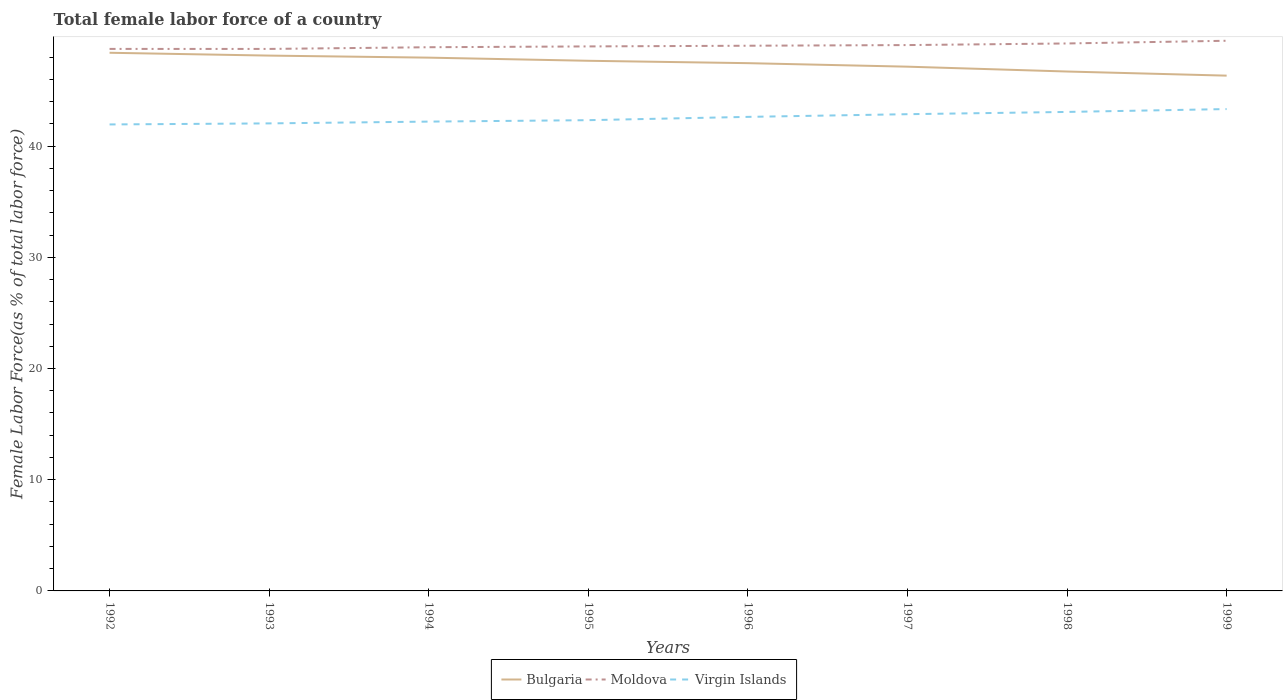Across all years, what is the maximum percentage of female labor force in Bulgaria?
Your answer should be compact. 46.34. What is the total percentage of female labor force in Virgin Islands in the graph?
Your answer should be very brief. -0.29. What is the difference between the highest and the second highest percentage of female labor force in Virgin Islands?
Give a very brief answer. 1.38. Is the percentage of female labor force in Moldova strictly greater than the percentage of female labor force in Virgin Islands over the years?
Give a very brief answer. No. How many lines are there?
Offer a very short reply. 3. Are the values on the major ticks of Y-axis written in scientific E-notation?
Your response must be concise. No. Where does the legend appear in the graph?
Ensure brevity in your answer.  Bottom center. What is the title of the graph?
Offer a very short reply. Total female labor force of a country. What is the label or title of the X-axis?
Make the answer very short. Years. What is the label or title of the Y-axis?
Your response must be concise. Female Labor Force(as % of total labor force). What is the Female Labor Force(as % of total labor force) of Bulgaria in 1992?
Make the answer very short. 48.39. What is the Female Labor Force(as % of total labor force) in Moldova in 1992?
Your response must be concise. 48.74. What is the Female Labor Force(as % of total labor force) in Virgin Islands in 1992?
Your response must be concise. 41.95. What is the Female Labor Force(as % of total labor force) in Bulgaria in 1993?
Your answer should be very brief. 48.14. What is the Female Labor Force(as % of total labor force) of Moldova in 1993?
Make the answer very short. 48.74. What is the Female Labor Force(as % of total labor force) of Virgin Islands in 1993?
Your answer should be very brief. 42.04. What is the Female Labor Force(as % of total labor force) of Bulgaria in 1994?
Give a very brief answer. 47.95. What is the Female Labor Force(as % of total labor force) in Moldova in 1994?
Give a very brief answer. 48.89. What is the Female Labor Force(as % of total labor force) in Virgin Islands in 1994?
Provide a succinct answer. 42.2. What is the Female Labor Force(as % of total labor force) of Bulgaria in 1995?
Make the answer very short. 47.67. What is the Female Labor Force(as % of total labor force) of Moldova in 1995?
Offer a very short reply. 48.96. What is the Female Labor Force(as % of total labor force) of Virgin Islands in 1995?
Provide a succinct answer. 42.33. What is the Female Labor Force(as % of total labor force) in Bulgaria in 1996?
Offer a terse response. 47.46. What is the Female Labor Force(as % of total labor force) of Moldova in 1996?
Make the answer very short. 49.03. What is the Female Labor Force(as % of total labor force) in Virgin Islands in 1996?
Offer a terse response. 42.63. What is the Female Labor Force(as % of total labor force) of Bulgaria in 1997?
Give a very brief answer. 47.14. What is the Female Labor Force(as % of total labor force) in Moldova in 1997?
Offer a very short reply. 49.08. What is the Female Labor Force(as % of total labor force) of Virgin Islands in 1997?
Your answer should be very brief. 42.87. What is the Female Labor Force(as % of total labor force) of Bulgaria in 1998?
Make the answer very short. 46.71. What is the Female Labor Force(as % of total labor force) of Moldova in 1998?
Offer a terse response. 49.23. What is the Female Labor Force(as % of total labor force) of Virgin Islands in 1998?
Give a very brief answer. 43.07. What is the Female Labor Force(as % of total labor force) of Bulgaria in 1999?
Offer a terse response. 46.34. What is the Female Labor Force(as % of total labor force) of Moldova in 1999?
Offer a very short reply. 49.47. What is the Female Labor Force(as % of total labor force) in Virgin Islands in 1999?
Keep it short and to the point. 43.33. Across all years, what is the maximum Female Labor Force(as % of total labor force) of Bulgaria?
Keep it short and to the point. 48.39. Across all years, what is the maximum Female Labor Force(as % of total labor force) of Moldova?
Ensure brevity in your answer.  49.47. Across all years, what is the maximum Female Labor Force(as % of total labor force) of Virgin Islands?
Provide a succinct answer. 43.33. Across all years, what is the minimum Female Labor Force(as % of total labor force) in Bulgaria?
Provide a short and direct response. 46.34. Across all years, what is the minimum Female Labor Force(as % of total labor force) of Moldova?
Your answer should be very brief. 48.74. Across all years, what is the minimum Female Labor Force(as % of total labor force) of Virgin Islands?
Provide a short and direct response. 41.95. What is the total Female Labor Force(as % of total labor force) in Bulgaria in the graph?
Your answer should be very brief. 379.8. What is the total Female Labor Force(as % of total labor force) in Moldova in the graph?
Keep it short and to the point. 392.14. What is the total Female Labor Force(as % of total labor force) in Virgin Islands in the graph?
Provide a succinct answer. 340.42. What is the difference between the Female Labor Force(as % of total labor force) in Bulgaria in 1992 and that in 1993?
Ensure brevity in your answer.  0.26. What is the difference between the Female Labor Force(as % of total labor force) of Moldova in 1992 and that in 1993?
Provide a short and direct response. 0. What is the difference between the Female Labor Force(as % of total labor force) in Virgin Islands in 1992 and that in 1993?
Provide a succinct answer. -0.1. What is the difference between the Female Labor Force(as % of total labor force) of Bulgaria in 1992 and that in 1994?
Keep it short and to the point. 0.44. What is the difference between the Female Labor Force(as % of total labor force) of Moldova in 1992 and that in 1994?
Ensure brevity in your answer.  -0.15. What is the difference between the Female Labor Force(as % of total labor force) of Virgin Islands in 1992 and that in 1994?
Your response must be concise. -0.26. What is the difference between the Female Labor Force(as % of total labor force) in Bulgaria in 1992 and that in 1995?
Provide a succinct answer. 0.72. What is the difference between the Female Labor Force(as % of total labor force) of Moldova in 1992 and that in 1995?
Give a very brief answer. -0.22. What is the difference between the Female Labor Force(as % of total labor force) of Virgin Islands in 1992 and that in 1995?
Offer a very short reply. -0.38. What is the difference between the Female Labor Force(as % of total labor force) in Bulgaria in 1992 and that in 1996?
Your response must be concise. 0.93. What is the difference between the Female Labor Force(as % of total labor force) of Moldova in 1992 and that in 1996?
Offer a terse response. -0.29. What is the difference between the Female Labor Force(as % of total labor force) in Virgin Islands in 1992 and that in 1996?
Keep it short and to the point. -0.68. What is the difference between the Female Labor Force(as % of total labor force) of Bulgaria in 1992 and that in 1997?
Keep it short and to the point. 1.25. What is the difference between the Female Labor Force(as % of total labor force) of Moldova in 1992 and that in 1997?
Provide a succinct answer. -0.34. What is the difference between the Female Labor Force(as % of total labor force) in Virgin Islands in 1992 and that in 1997?
Keep it short and to the point. -0.92. What is the difference between the Female Labor Force(as % of total labor force) in Bulgaria in 1992 and that in 1998?
Give a very brief answer. 1.69. What is the difference between the Female Labor Force(as % of total labor force) of Moldova in 1992 and that in 1998?
Offer a terse response. -0.49. What is the difference between the Female Labor Force(as % of total labor force) in Virgin Islands in 1992 and that in 1998?
Give a very brief answer. -1.13. What is the difference between the Female Labor Force(as % of total labor force) in Bulgaria in 1992 and that in 1999?
Offer a terse response. 2.06. What is the difference between the Female Labor Force(as % of total labor force) of Moldova in 1992 and that in 1999?
Offer a terse response. -0.73. What is the difference between the Female Labor Force(as % of total labor force) of Virgin Islands in 1992 and that in 1999?
Your answer should be very brief. -1.38. What is the difference between the Female Labor Force(as % of total labor force) in Bulgaria in 1993 and that in 1994?
Offer a terse response. 0.18. What is the difference between the Female Labor Force(as % of total labor force) in Moldova in 1993 and that in 1994?
Make the answer very short. -0.15. What is the difference between the Female Labor Force(as % of total labor force) of Virgin Islands in 1993 and that in 1994?
Your answer should be compact. -0.16. What is the difference between the Female Labor Force(as % of total labor force) of Bulgaria in 1993 and that in 1995?
Make the answer very short. 0.47. What is the difference between the Female Labor Force(as % of total labor force) of Moldova in 1993 and that in 1995?
Offer a very short reply. -0.23. What is the difference between the Female Labor Force(as % of total labor force) in Virgin Islands in 1993 and that in 1995?
Give a very brief answer. -0.29. What is the difference between the Female Labor Force(as % of total labor force) in Bulgaria in 1993 and that in 1996?
Give a very brief answer. 0.68. What is the difference between the Female Labor Force(as % of total labor force) in Moldova in 1993 and that in 1996?
Your response must be concise. -0.29. What is the difference between the Female Labor Force(as % of total labor force) of Virgin Islands in 1993 and that in 1996?
Keep it short and to the point. -0.59. What is the difference between the Female Labor Force(as % of total labor force) of Moldova in 1993 and that in 1997?
Offer a very short reply. -0.35. What is the difference between the Female Labor Force(as % of total labor force) in Virgin Islands in 1993 and that in 1997?
Provide a succinct answer. -0.83. What is the difference between the Female Labor Force(as % of total labor force) of Bulgaria in 1993 and that in 1998?
Make the answer very short. 1.43. What is the difference between the Female Labor Force(as % of total labor force) in Moldova in 1993 and that in 1998?
Offer a very short reply. -0.49. What is the difference between the Female Labor Force(as % of total labor force) in Virgin Islands in 1993 and that in 1998?
Give a very brief answer. -1.03. What is the difference between the Female Labor Force(as % of total labor force) in Bulgaria in 1993 and that in 1999?
Offer a terse response. 1.8. What is the difference between the Female Labor Force(as % of total labor force) of Moldova in 1993 and that in 1999?
Your answer should be very brief. -0.73. What is the difference between the Female Labor Force(as % of total labor force) of Virgin Islands in 1993 and that in 1999?
Give a very brief answer. -1.29. What is the difference between the Female Labor Force(as % of total labor force) of Bulgaria in 1994 and that in 1995?
Provide a short and direct response. 0.28. What is the difference between the Female Labor Force(as % of total labor force) in Moldova in 1994 and that in 1995?
Keep it short and to the point. -0.07. What is the difference between the Female Labor Force(as % of total labor force) in Virgin Islands in 1994 and that in 1995?
Keep it short and to the point. -0.13. What is the difference between the Female Labor Force(as % of total labor force) of Bulgaria in 1994 and that in 1996?
Provide a succinct answer. 0.5. What is the difference between the Female Labor Force(as % of total labor force) of Moldova in 1994 and that in 1996?
Make the answer very short. -0.13. What is the difference between the Female Labor Force(as % of total labor force) of Virgin Islands in 1994 and that in 1996?
Provide a short and direct response. -0.42. What is the difference between the Female Labor Force(as % of total labor force) of Bulgaria in 1994 and that in 1997?
Provide a short and direct response. 0.81. What is the difference between the Female Labor Force(as % of total labor force) of Moldova in 1994 and that in 1997?
Your answer should be very brief. -0.19. What is the difference between the Female Labor Force(as % of total labor force) of Virgin Islands in 1994 and that in 1997?
Offer a terse response. -0.67. What is the difference between the Female Labor Force(as % of total labor force) of Bulgaria in 1994 and that in 1998?
Your answer should be compact. 1.25. What is the difference between the Female Labor Force(as % of total labor force) in Moldova in 1994 and that in 1998?
Your response must be concise. -0.34. What is the difference between the Female Labor Force(as % of total labor force) of Virgin Islands in 1994 and that in 1998?
Your response must be concise. -0.87. What is the difference between the Female Labor Force(as % of total labor force) in Bulgaria in 1994 and that in 1999?
Provide a succinct answer. 1.62. What is the difference between the Female Labor Force(as % of total labor force) of Moldova in 1994 and that in 1999?
Provide a succinct answer. -0.58. What is the difference between the Female Labor Force(as % of total labor force) of Virgin Islands in 1994 and that in 1999?
Your response must be concise. -1.13. What is the difference between the Female Labor Force(as % of total labor force) in Bulgaria in 1995 and that in 1996?
Make the answer very short. 0.21. What is the difference between the Female Labor Force(as % of total labor force) of Moldova in 1995 and that in 1996?
Your response must be concise. -0.06. What is the difference between the Female Labor Force(as % of total labor force) of Virgin Islands in 1995 and that in 1996?
Offer a terse response. -0.3. What is the difference between the Female Labor Force(as % of total labor force) of Bulgaria in 1995 and that in 1997?
Provide a succinct answer. 0.53. What is the difference between the Female Labor Force(as % of total labor force) in Moldova in 1995 and that in 1997?
Offer a terse response. -0.12. What is the difference between the Female Labor Force(as % of total labor force) in Virgin Islands in 1995 and that in 1997?
Your answer should be compact. -0.54. What is the difference between the Female Labor Force(as % of total labor force) of Bulgaria in 1995 and that in 1998?
Your answer should be compact. 0.97. What is the difference between the Female Labor Force(as % of total labor force) in Moldova in 1995 and that in 1998?
Offer a very short reply. -0.27. What is the difference between the Female Labor Force(as % of total labor force) of Virgin Islands in 1995 and that in 1998?
Ensure brevity in your answer.  -0.74. What is the difference between the Female Labor Force(as % of total labor force) of Bulgaria in 1995 and that in 1999?
Provide a short and direct response. 1.34. What is the difference between the Female Labor Force(as % of total labor force) of Moldova in 1995 and that in 1999?
Offer a terse response. -0.51. What is the difference between the Female Labor Force(as % of total labor force) of Virgin Islands in 1995 and that in 1999?
Keep it short and to the point. -1. What is the difference between the Female Labor Force(as % of total labor force) of Bulgaria in 1996 and that in 1997?
Offer a terse response. 0.32. What is the difference between the Female Labor Force(as % of total labor force) of Moldova in 1996 and that in 1997?
Your response must be concise. -0.06. What is the difference between the Female Labor Force(as % of total labor force) in Virgin Islands in 1996 and that in 1997?
Keep it short and to the point. -0.24. What is the difference between the Female Labor Force(as % of total labor force) of Bulgaria in 1996 and that in 1998?
Ensure brevity in your answer.  0.75. What is the difference between the Female Labor Force(as % of total labor force) of Moldova in 1996 and that in 1998?
Ensure brevity in your answer.  -0.2. What is the difference between the Female Labor Force(as % of total labor force) of Virgin Islands in 1996 and that in 1998?
Offer a very short reply. -0.44. What is the difference between the Female Labor Force(as % of total labor force) of Bulgaria in 1996 and that in 1999?
Offer a terse response. 1.12. What is the difference between the Female Labor Force(as % of total labor force) of Moldova in 1996 and that in 1999?
Make the answer very short. -0.45. What is the difference between the Female Labor Force(as % of total labor force) in Virgin Islands in 1996 and that in 1999?
Your answer should be very brief. -0.7. What is the difference between the Female Labor Force(as % of total labor force) in Bulgaria in 1997 and that in 1998?
Provide a short and direct response. 0.44. What is the difference between the Female Labor Force(as % of total labor force) of Moldova in 1997 and that in 1998?
Keep it short and to the point. -0.15. What is the difference between the Female Labor Force(as % of total labor force) in Virgin Islands in 1997 and that in 1998?
Offer a terse response. -0.2. What is the difference between the Female Labor Force(as % of total labor force) in Bulgaria in 1997 and that in 1999?
Keep it short and to the point. 0.81. What is the difference between the Female Labor Force(as % of total labor force) in Moldova in 1997 and that in 1999?
Offer a very short reply. -0.39. What is the difference between the Female Labor Force(as % of total labor force) of Virgin Islands in 1997 and that in 1999?
Your answer should be compact. -0.46. What is the difference between the Female Labor Force(as % of total labor force) of Bulgaria in 1998 and that in 1999?
Keep it short and to the point. 0.37. What is the difference between the Female Labor Force(as % of total labor force) of Moldova in 1998 and that in 1999?
Keep it short and to the point. -0.24. What is the difference between the Female Labor Force(as % of total labor force) of Virgin Islands in 1998 and that in 1999?
Provide a short and direct response. -0.26. What is the difference between the Female Labor Force(as % of total labor force) of Bulgaria in 1992 and the Female Labor Force(as % of total labor force) of Moldova in 1993?
Give a very brief answer. -0.34. What is the difference between the Female Labor Force(as % of total labor force) in Bulgaria in 1992 and the Female Labor Force(as % of total labor force) in Virgin Islands in 1993?
Make the answer very short. 6.35. What is the difference between the Female Labor Force(as % of total labor force) of Moldova in 1992 and the Female Labor Force(as % of total labor force) of Virgin Islands in 1993?
Ensure brevity in your answer.  6.7. What is the difference between the Female Labor Force(as % of total labor force) in Bulgaria in 1992 and the Female Labor Force(as % of total labor force) in Moldova in 1994?
Make the answer very short. -0.5. What is the difference between the Female Labor Force(as % of total labor force) of Bulgaria in 1992 and the Female Labor Force(as % of total labor force) of Virgin Islands in 1994?
Make the answer very short. 6.19. What is the difference between the Female Labor Force(as % of total labor force) in Moldova in 1992 and the Female Labor Force(as % of total labor force) in Virgin Islands in 1994?
Keep it short and to the point. 6.54. What is the difference between the Female Labor Force(as % of total labor force) in Bulgaria in 1992 and the Female Labor Force(as % of total labor force) in Moldova in 1995?
Ensure brevity in your answer.  -0.57. What is the difference between the Female Labor Force(as % of total labor force) in Bulgaria in 1992 and the Female Labor Force(as % of total labor force) in Virgin Islands in 1995?
Make the answer very short. 6.06. What is the difference between the Female Labor Force(as % of total labor force) of Moldova in 1992 and the Female Labor Force(as % of total labor force) of Virgin Islands in 1995?
Give a very brief answer. 6.41. What is the difference between the Female Labor Force(as % of total labor force) of Bulgaria in 1992 and the Female Labor Force(as % of total labor force) of Moldova in 1996?
Your answer should be very brief. -0.63. What is the difference between the Female Labor Force(as % of total labor force) of Bulgaria in 1992 and the Female Labor Force(as % of total labor force) of Virgin Islands in 1996?
Your answer should be compact. 5.76. What is the difference between the Female Labor Force(as % of total labor force) of Moldova in 1992 and the Female Labor Force(as % of total labor force) of Virgin Islands in 1996?
Offer a terse response. 6.11. What is the difference between the Female Labor Force(as % of total labor force) of Bulgaria in 1992 and the Female Labor Force(as % of total labor force) of Moldova in 1997?
Your answer should be compact. -0.69. What is the difference between the Female Labor Force(as % of total labor force) of Bulgaria in 1992 and the Female Labor Force(as % of total labor force) of Virgin Islands in 1997?
Make the answer very short. 5.52. What is the difference between the Female Labor Force(as % of total labor force) of Moldova in 1992 and the Female Labor Force(as % of total labor force) of Virgin Islands in 1997?
Your answer should be compact. 5.87. What is the difference between the Female Labor Force(as % of total labor force) of Bulgaria in 1992 and the Female Labor Force(as % of total labor force) of Moldova in 1998?
Offer a terse response. -0.84. What is the difference between the Female Labor Force(as % of total labor force) of Bulgaria in 1992 and the Female Labor Force(as % of total labor force) of Virgin Islands in 1998?
Offer a terse response. 5.32. What is the difference between the Female Labor Force(as % of total labor force) of Moldova in 1992 and the Female Labor Force(as % of total labor force) of Virgin Islands in 1998?
Ensure brevity in your answer.  5.67. What is the difference between the Female Labor Force(as % of total labor force) in Bulgaria in 1992 and the Female Labor Force(as % of total labor force) in Moldova in 1999?
Ensure brevity in your answer.  -1.08. What is the difference between the Female Labor Force(as % of total labor force) of Bulgaria in 1992 and the Female Labor Force(as % of total labor force) of Virgin Islands in 1999?
Offer a terse response. 5.06. What is the difference between the Female Labor Force(as % of total labor force) of Moldova in 1992 and the Female Labor Force(as % of total labor force) of Virgin Islands in 1999?
Keep it short and to the point. 5.41. What is the difference between the Female Labor Force(as % of total labor force) of Bulgaria in 1993 and the Female Labor Force(as % of total labor force) of Moldova in 1994?
Your answer should be very brief. -0.75. What is the difference between the Female Labor Force(as % of total labor force) in Bulgaria in 1993 and the Female Labor Force(as % of total labor force) in Virgin Islands in 1994?
Keep it short and to the point. 5.93. What is the difference between the Female Labor Force(as % of total labor force) in Moldova in 1993 and the Female Labor Force(as % of total labor force) in Virgin Islands in 1994?
Offer a terse response. 6.53. What is the difference between the Female Labor Force(as % of total labor force) of Bulgaria in 1993 and the Female Labor Force(as % of total labor force) of Moldova in 1995?
Provide a succinct answer. -0.83. What is the difference between the Female Labor Force(as % of total labor force) of Bulgaria in 1993 and the Female Labor Force(as % of total labor force) of Virgin Islands in 1995?
Your response must be concise. 5.81. What is the difference between the Female Labor Force(as % of total labor force) in Moldova in 1993 and the Female Labor Force(as % of total labor force) in Virgin Islands in 1995?
Your answer should be compact. 6.41. What is the difference between the Female Labor Force(as % of total labor force) in Bulgaria in 1993 and the Female Labor Force(as % of total labor force) in Moldova in 1996?
Provide a succinct answer. -0.89. What is the difference between the Female Labor Force(as % of total labor force) in Bulgaria in 1993 and the Female Labor Force(as % of total labor force) in Virgin Islands in 1996?
Make the answer very short. 5.51. What is the difference between the Female Labor Force(as % of total labor force) in Moldova in 1993 and the Female Labor Force(as % of total labor force) in Virgin Islands in 1996?
Your answer should be compact. 6.11. What is the difference between the Female Labor Force(as % of total labor force) of Bulgaria in 1993 and the Female Labor Force(as % of total labor force) of Moldova in 1997?
Your response must be concise. -0.95. What is the difference between the Female Labor Force(as % of total labor force) in Bulgaria in 1993 and the Female Labor Force(as % of total labor force) in Virgin Islands in 1997?
Ensure brevity in your answer.  5.27. What is the difference between the Female Labor Force(as % of total labor force) of Moldova in 1993 and the Female Labor Force(as % of total labor force) of Virgin Islands in 1997?
Make the answer very short. 5.87. What is the difference between the Female Labor Force(as % of total labor force) in Bulgaria in 1993 and the Female Labor Force(as % of total labor force) in Moldova in 1998?
Provide a succinct answer. -1.09. What is the difference between the Female Labor Force(as % of total labor force) of Bulgaria in 1993 and the Female Labor Force(as % of total labor force) of Virgin Islands in 1998?
Provide a succinct answer. 5.07. What is the difference between the Female Labor Force(as % of total labor force) of Moldova in 1993 and the Female Labor Force(as % of total labor force) of Virgin Islands in 1998?
Give a very brief answer. 5.67. What is the difference between the Female Labor Force(as % of total labor force) of Bulgaria in 1993 and the Female Labor Force(as % of total labor force) of Moldova in 1999?
Provide a short and direct response. -1.33. What is the difference between the Female Labor Force(as % of total labor force) of Bulgaria in 1993 and the Female Labor Force(as % of total labor force) of Virgin Islands in 1999?
Provide a short and direct response. 4.81. What is the difference between the Female Labor Force(as % of total labor force) of Moldova in 1993 and the Female Labor Force(as % of total labor force) of Virgin Islands in 1999?
Your answer should be very brief. 5.41. What is the difference between the Female Labor Force(as % of total labor force) in Bulgaria in 1994 and the Female Labor Force(as % of total labor force) in Moldova in 1995?
Ensure brevity in your answer.  -1.01. What is the difference between the Female Labor Force(as % of total labor force) of Bulgaria in 1994 and the Female Labor Force(as % of total labor force) of Virgin Islands in 1995?
Offer a terse response. 5.62. What is the difference between the Female Labor Force(as % of total labor force) of Moldova in 1994 and the Female Labor Force(as % of total labor force) of Virgin Islands in 1995?
Keep it short and to the point. 6.56. What is the difference between the Female Labor Force(as % of total labor force) of Bulgaria in 1994 and the Female Labor Force(as % of total labor force) of Moldova in 1996?
Provide a succinct answer. -1.07. What is the difference between the Female Labor Force(as % of total labor force) in Bulgaria in 1994 and the Female Labor Force(as % of total labor force) in Virgin Islands in 1996?
Offer a terse response. 5.33. What is the difference between the Female Labor Force(as % of total labor force) in Moldova in 1994 and the Female Labor Force(as % of total labor force) in Virgin Islands in 1996?
Your answer should be compact. 6.26. What is the difference between the Female Labor Force(as % of total labor force) of Bulgaria in 1994 and the Female Labor Force(as % of total labor force) of Moldova in 1997?
Your answer should be very brief. -1.13. What is the difference between the Female Labor Force(as % of total labor force) of Bulgaria in 1994 and the Female Labor Force(as % of total labor force) of Virgin Islands in 1997?
Offer a very short reply. 5.09. What is the difference between the Female Labor Force(as % of total labor force) in Moldova in 1994 and the Female Labor Force(as % of total labor force) in Virgin Islands in 1997?
Your answer should be compact. 6.02. What is the difference between the Female Labor Force(as % of total labor force) in Bulgaria in 1994 and the Female Labor Force(as % of total labor force) in Moldova in 1998?
Provide a short and direct response. -1.27. What is the difference between the Female Labor Force(as % of total labor force) of Bulgaria in 1994 and the Female Labor Force(as % of total labor force) of Virgin Islands in 1998?
Offer a very short reply. 4.88. What is the difference between the Female Labor Force(as % of total labor force) in Moldova in 1994 and the Female Labor Force(as % of total labor force) in Virgin Islands in 1998?
Give a very brief answer. 5.82. What is the difference between the Female Labor Force(as % of total labor force) of Bulgaria in 1994 and the Female Labor Force(as % of total labor force) of Moldova in 1999?
Your answer should be compact. -1.52. What is the difference between the Female Labor Force(as % of total labor force) in Bulgaria in 1994 and the Female Labor Force(as % of total labor force) in Virgin Islands in 1999?
Make the answer very short. 4.62. What is the difference between the Female Labor Force(as % of total labor force) in Moldova in 1994 and the Female Labor Force(as % of total labor force) in Virgin Islands in 1999?
Your response must be concise. 5.56. What is the difference between the Female Labor Force(as % of total labor force) of Bulgaria in 1995 and the Female Labor Force(as % of total labor force) of Moldova in 1996?
Offer a terse response. -1.35. What is the difference between the Female Labor Force(as % of total labor force) in Bulgaria in 1995 and the Female Labor Force(as % of total labor force) in Virgin Islands in 1996?
Your answer should be very brief. 5.04. What is the difference between the Female Labor Force(as % of total labor force) in Moldova in 1995 and the Female Labor Force(as % of total labor force) in Virgin Islands in 1996?
Make the answer very short. 6.34. What is the difference between the Female Labor Force(as % of total labor force) of Bulgaria in 1995 and the Female Labor Force(as % of total labor force) of Moldova in 1997?
Your response must be concise. -1.41. What is the difference between the Female Labor Force(as % of total labor force) in Bulgaria in 1995 and the Female Labor Force(as % of total labor force) in Virgin Islands in 1997?
Ensure brevity in your answer.  4.8. What is the difference between the Female Labor Force(as % of total labor force) in Moldova in 1995 and the Female Labor Force(as % of total labor force) in Virgin Islands in 1997?
Keep it short and to the point. 6.09. What is the difference between the Female Labor Force(as % of total labor force) in Bulgaria in 1995 and the Female Labor Force(as % of total labor force) in Moldova in 1998?
Give a very brief answer. -1.56. What is the difference between the Female Labor Force(as % of total labor force) of Bulgaria in 1995 and the Female Labor Force(as % of total labor force) of Virgin Islands in 1998?
Provide a succinct answer. 4.6. What is the difference between the Female Labor Force(as % of total labor force) of Moldova in 1995 and the Female Labor Force(as % of total labor force) of Virgin Islands in 1998?
Ensure brevity in your answer.  5.89. What is the difference between the Female Labor Force(as % of total labor force) in Bulgaria in 1995 and the Female Labor Force(as % of total labor force) in Moldova in 1999?
Ensure brevity in your answer.  -1.8. What is the difference between the Female Labor Force(as % of total labor force) in Bulgaria in 1995 and the Female Labor Force(as % of total labor force) in Virgin Islands in 1999?
Give a very brief answer. 4.34. What is the difference between the Female Labor Force(as % of total labor force) in Moldova in 1995 and the Female Labor Force(as % of total labor force) in Virgin Islands in 1999?
Give a very brief answer. 5.63. What is the difference between the Female Labor Force(as % of total labor force) of Bulgaria in 1996 and the Female Labor Force(as % of total labor force) of Moldova in 1997?
Ensure brevity in your answer.  -1.63. What is the difference between the Female Labor Force(as % of total labor force) in Bulgaria in 1996 and the Female Labor Force(as % of total labor force) in Virgin Islands in 1997?
Your answer should be compact. 4.59. What is the difference between the Female Labor Force(as % of total labor force) of Moldova in 1996 and the Female Labor Force(as % of total labor force) of Virgin Islands in 1997?
Offer a terse response. 6.16. What is the difference between the Female Labor Force(as % of total labor force) in Bulgaria in 1996 and the Female Labor Force(as % of total labor force) in Moldova in 1998?
Your response must be concise. -1.77. What is the difference between the Female Labor Force(as % of total labor force) of Bulgaria in 1996 and the Female Labor Force(as % of total labor force) of Virgin Islands in 1998?
Give a very brief answer. 4.39. What is the difference between the Female Labor Force(as % of total labor force) of Moldova in 1996 and the Female Labor Force(as % of total labor force) of Virgin Islands in 1998?
Provide a short and direct response. 5.95. What is the difference between the Female Labor Force(as % of total labor force) of Bulgaria in 1996 and the Female Labor Force(as % of total labor force) of Moldova in 1999?
Offer a very short reply. -2.01. What is the difference between the Female Labor Force(as % of total labor force) of Bulgaria in 1996 and the Female Labor Force(as % of total labor force) of Virgin Islands in 1999?
Keep it short and to the point. 4.13. What is the difference between the Female Labor Force(as % of total labor force) of Moldova in 1996 and the Female Labor Force(as % of total labor force) of Virgin Islands in 1999?
Your answer should be compact. 5.7. What is the difference between the Female Labor Force(as % of total labor force) of Bulgaria in 1997 and the Female Labor Force(as % of total labor force) of Moldova in 1998?
Your response must be concise. -2.09. What is the difference between the Female Labor Force(as % of total labor force) of Bulgaria in 1997 and the Female Labor Force(as % of total labor force) of Virgin Islands in 1998?
Make the answer very short. 4.07. What is the difference between the Female Labor Force(as % of total labor force) in Moldova in 1997 and the Female Labor Force(as % of total labor force) in Virgin Islands in 1998?
Ensure brevity in your answer.  6.01. What is the difference between the Female Labor Force(as % of total labor force) of Bulgaria in 1997 and the Female Labor Force(as % of total labor force) of Moldova in 1999?
Your answer should be compact. -2.33. What is the difference between the Female Labor Force(as % of total labor force) in Bulgaria in 1997 and the Female Labor Force(as % of total labor force) in Virgin Islands in 1999?
Make the answer very short. 3.81. What is the difference between the Female Labor Force(as % of total labor force) in Moldova in 1997 and the Female Labor Force(as % of total labor force) in Virgin Islands in 1999?
Your answer should be very brief. 5.75. What is the difference between the Female Labor Force(as % of total labor force) of Bulgaria in 1998 and the Female Labor Force(as % of total labor force) of Moldova in 1999?
Offer a very short reply. -2.77. What is the difference between the Female Labor Force(as % of total labor force) in Bulgaria in 1998 and the Female Labor Force(as % of total labor force) in Virgin Islands in 1999?
Provide a succinct answer. 3.38. What is the difference between the Female Labor Force(as % of total labor force) in Moldova in 1998 and the Female Labor Force(as % of total labor force) in Virgin Islands in 1999?
Your response must be concise. 5.9. What is the average Female Labor Force(as % of total labor force) of Bulgaria per year?
Your answer should be compact. 47.48. What is the average Female Labor Force(as % of total labor force) in Moldova per year?
Your response must be concise. 49.02. What is the average Female Labor Force(as % of total labor force) of Virgin Islands per year?
Provide a short and direct response. 42.55. In the year 1992, what is the difference between the Female Labor Force(as % of total labor force) of Bulgaria and Female Labor Force(as % of total labor force) of Moldova?
Provide a succinct answer. -0.35. In the year 1992, what is the difference between the Female Labor Force(as % of total labor force) of Bulgaria and Female Labor Force(as % of total labor force) of Virgin Islands?
Make the answer very short. 6.45. In the year 1992, what is the difference between the Female Labor Force(as % of total labor force) in Moldova and Female Labor Force(as % of total labor force) in Virgin Islands?
Make the answer very short. 6.79. In the year 1993, what is the difference between the Female Labor Force(as % of total labor force) of Bulgaria and Female Labor Force(as % of total labor force) of Moldova?
Offer a terse response. -0.6. In the year 1993, what is the difference between the Female Labor Force(as % of total labor force) in Bulgaria and Female Labor Force(as % of total labor force) in Virgin Islands?
Offer a very short reply. 6.1. In the year 1993, what is the difference between the Female Labor Force(as % of total labor force) of Moldova and Female Labor Force(as % of total labor force) of Virgin Islands?
Offer a terse response. 6.7. In the year 1994, what is the difference between the Female Labor Force(as % of total labor force) of Bulgaria and Female Labor Force(as % of total labor force) of Moldova?
Your response must be concise. -0.94. In the year 1994, what is the difference between the Female Labor Force(as % of total labor force) of Bulgaria and Female Labor Force(as % of total labor force) of Virgin Islands?
Provide a short and direct response. 5.75. In the year 1994, what is the difference between the Female Labor Force(as % of total labor force) in Moldova and Female Labor Force(as % of total labor force) in Virgin Islands?
Your answer should be very brief. 6.69. In the year 1995, what is the difference between the Female Labor Force(as % of total labor force) in Bulgaria and Female Labor Force(as % of total labor force) in Moldova?
Keep it short and to the point. -1.29. In the year 1995, what is the difference between the Female Labor Force(as % of total labor force) of Bulgaria and Female Labor Force(as % of total labor force) of Virgin Islands?
Your answer should be compact. 5.34. In the year 1995, what is the difference between the Female Labor Force(as % of total labor force) of Moldova and Female Labor Force(as % of total labor force) of Virgin Islands?
Offer a terse response. 6.63. In the year 1996, what is the difference between the Female Labor Force(as % of total labor force) of Bulgaria and Female Labor Force(as % of total labor force) of Moldova?
Ensure brevity in your answer.  -1.57. In the year 1996, what is the difference between the Female Labor Force(as % of total labor force) in Bulgaria and Female Labor Force(as % of total labor force) in Virgin Islands?
Give a very brief answer. 4.83. In the year 1996, what is the difference between the Female Labor Force(as % of total labor force) in Moldova and Female Labor Force(as % of total labor force) in Virgin Islands?
Provide a short and direct response. 6.4. In the year 1997, what is the difference between the Female Labor Force(as % of total labor force) of Bulgaria and Female Labor Force(as % of total labor force) of Moldova?
Make the answer very short. -1.94. In the year 1997, what is the difference between the Female Labor Force(as % of total labor force) in Bulgaria and Female Labor Force(as % of total labor force) in Virgin Islands?
Offer a very short reply. 4.27. In the year 1997, what is the difference between the Female Labor Force(as % of total labor force) of Moldova and Female Labor Force(as % of total labor force) of Virgin Islands?
Offer a very short reply. 6.21. In the year 1998, what is the difference between the Female Labor Force(as % of total labor force) in Bulgaria and Female Labor Force(as % of total labor force) in Moldova?
Provide a succinct answer. -2.52. In the year 1998, what is the difference between the Female Labor Force(as % of total labor force) in Bulgaria and Female Labor Force(as % of total labor force) in Virgin Islands?
Offer a very short reply. 3.63. In the year 1998, what is the difference between the Female Labor Force(as % of total labor force) in Moldova and Female Labor Force(as % of total labor force) in Virgin Islands?
Give a very brief answer. 6.16. In the year 1999, what is the difference between the Female Labor Force(as % of total labor force) in Bulgaria and Female Labor Force(as % of total labor force) in Moldova?
Your answer should be compact. -3.14. In the year 1999, what is the difference between the Female Labor Force(as % of total labor force) in Bulgaria and Female Labor Force(as % of total labor force) in Virgin Islands?
Ensure brevity in your answer.  3.01. In the year 1999, what is the difference between the Female Labor Force(as % of total labor force) in Moldova and Female Labor Force(as % of total labor force) in Virgin Islands?
Your answer should be very brief. 6.14. What is the ratio of the Female Labor Force(as % of total labor force) of Moldova in 1992 to that in 1993?
Provide a succinct answer. 1. What is the ratio of the Female Labor Force(as % of total labor force) of Virgin Islands in 1992 to that in 1993?
Give a very brief answer. 1. What is the ratio of the Female Labor Force(as % of total labor force) of Bulgaria in 1992 to that in 1994?
Your answer should be compact. 1.01. What is the ratio of the Female Labor Force(as % of total labor force) in Moldova in 1992 to that in 1994?
Your answer should be compact. 1. What is the ratio of the Female Labor Force(as % of total labor force) in Bulgaria in 1992 to that in 1995?
Make the answer very short. 1.02. What is the ratio of the Female Labor Force(as % of total labor force) in Moldova in 1992 to that in 1995?
Your answer should be very brief. 1. What is the ratio of the Female Labor Force(as % of total labor force) in Virgin Islands in 1992 to that in 1995?
Give a very brief answer. 0.99. What is the ratio of the Female Labor Force(as % of total labor force) of Bulgaria in 1992 to that in 1996?
Make the answer very short. 1.02. What is the ratio of the Female Labor Force(as % of total labor force) in Moldova in 1992 to that in 1996?
Ensure brevity in your answer.  0.99. What is the ratio of the Female Labor Force(as % of total labor force) in Bulgaria in 1992 to that in 1997?
Ensure brevity in your answer.  1.03. What is the ratio of the Female Labor Force(as % of total labor force) in Virgin Islands in 1992 to that in 1997?
Offer a terse response. 0.98. What is the ratio of the Female Labor Force(as % of total labor force) of Bulgaria in 1992 to that in 1998?
Make the answer very short. 1.04. What is the ratio of the Female Labor Force(as % of total labor force) in Moldova in 1992 to that in 1998?
Give a very brief answer. 0.99. What is the ratio of the Female Labor Force(as % of total labor force) in Virgin Islands in 1992 to that in 1998?
Offer a very short reply. 0.97. What is the ratio of the Female Labor Force(as % of total labor force) of Bulgaria in 1992 to that in 1999?
Offer a very short reply. 1.04. What is the ratio of the Female Labor Force(as % of total labor force) in Moldova in 1992 to that in 1999?
Your answer should be compact. 0.99. What is the ratio of the Female Labor Force(as % of total labor force) in Virgin Islands in 1992 to that in 1999?
Keep it short and to the point. 0.97. What is the ratio of the Female Labor Force(as % of total labor force) of Virgin Islands in 1993 to that in 1994?
Offer a terse response. 1. What is the ratio of the Female Labor Force(as % of total labor force) of Bulgaria in 1993 to that in 1995?
Provide a succinct answer. 1.01. What is the ratio of the Female Labor Force(as % of total labor force) in Moldova in 1993 to that in 1995?
Offer a terse response. 1. What is the ratio of the Female Labor Force(as % of total labor force) of Bulgaria in 1993 to that in 1996?
Your answer should be compact. 1.01. What is the ratio of the Female Labor Force(as % of total labor force) of Virgin Islands in 1993 to that in 1996?
Offer a very short reply. 0.99. What is the ratio of the Female Labor Force(as % of total labor force) of Bulgaria in 1993 to that in 1997?
Give a very brief answer. 1.02. What is the ratio of the Female Labor Force(as % of total labor force) of Virgin Islands in 1993 to that in 1997?
Your response must be concise. 0.98. What is the ratio of the Female Labor Force(as % of total labor force) in Bulgaria in 1993 to that in 1998?
Give a very brief answer. 1.03. What is the ratio of the Female Labor Force(as % of total labor force) in Virgin Islands in 1993 to that in 1998?
Your answer should be compact. 0.98. What is the ratio of the Female Labor Force(as % of total labor force) in Bulgaria in 1993 to that in 1999?
Your answer should be compact. 1.04. What is the ratio of the Female Labor Force(as % of total labor force) in Moldova in 1993 to that in 1999?
Your answer should be very brief. 0.99. What is the ratio of the Female Labor Force(as % of total labor force) in Virgin Islands in 1993 to that in 1999?
Give a very brief answer. 0.97. What is the ratio of the Female Labor Force(as % of total labor force) of Bulgaria in 1994 to that in 1995?
Offer a terse response. 1.01. What is the ratio of the Female Labor Force(as % of total labor force) in Virgin Islands in 1994 to that in 1995?
Provide a short and direct response. 1. What is the ratio of the Female Labor Force(as % of total labor force) in Bulgaria in 1994 to that in 1996?
Your answer should be compact. 1.01. What is the ratio of the Female Labor Force(as % of total labor force) in Moldova in 1994 to that in 1996?
Give a very brief answer. 1. What is the ratio of the Female Labor Force(as % of total labor force) of Virgin Islands in 1994 to that in 1996?
Give a very brief answer. 0.99. What is the ratio of the Female Labor Force(as % of total labor force) of Bulgaria in 1994 to that in 1997?
Provide a short and direct response. 1.02. What is the ratio of the Female Labor Force(as % of total labor force) in Moldova in 1994 to that in 1997?
Keep it short and to the point. 1. What is the ratio of the Female Labor Force(as % of total labor force) of Virgin Islands in 1994 to that in 1997?
Keep it short and to the point. 0.98. What is the ratio of the Female Labor Force(as % of total labor force) of Bulgaria in 1994 to that in 1998?
Offer a very short reply. 1.03. What is the ratio of the Female Labor Force(as % of total labor force) of Virgin Islands in 1994 to that in 1998?
Offer a terse response. 0.98. What is the ratio of the Female Labor Force(as % of total labor force) in Bulgaria in 1994 to that in 1999?
Keep it short and to the point. 1.03. What is the ratio of the Female Labor Force(as % of total labor force) of Moldova in 1995 to that in 1996?
Provide a short and direct response. 1. What is the ratio of the Female Labor Force(as % of total labor force) of Bulgaria in 1995 to that in 1997?
Provide a succinct answer. 1.01. What is the ratio of the Female Labor Force(as % of total labor force) of Virgin Islands in 1995 to that in 1997?
Provide a succinct answer. 0.99. What is the ratio of the Female Labor Force(as % of total labor force) in Bulgaria in 1995 to that in 1998?
Your answer should be compact. 1.02. What is the ratio of the Female Labor Force(as % of total labor force) in Virgin Islands in 1995 to that in 1998?
Your response must be concise. 0.98. What is the ratio of the Female Labor Force(as % of total labor force) of Bulgaria in 1995 to that in 1999?
Offer a terse response. 1.03. What is the ratio of the Female Labor Force(as % of total labor force) of Virgin Islands in 1995 to that in 1999?
Offer a very short reply. 0.98. What is the ratio of the Female Labor Force(as % of total labor force) of Bulgaria in 1996 to that in 1998?
Make the answer very short. 1.02. What is the ratio of the Female Labor Force(as % of total labor force) of Virgin Islands in 1996 to that in 1998?
Provide a short and direct response. 0.99. What is the ratio of the Female Labor Force(as % of total labor force) of Bulgaria in 1996 to that in 1999?
Offer a very short reply. 1.02. What is the ratio of the Female Labor Force(as % of total labor force) of Virgin Islands in 1996 to that in 1999?
Your answer should be compact. 0.98. What is the ratio of the Female Labor Force(as % of total labor force) of Bulgaria in 1997 to that in 1998?
Give a very brief answer. 1.01. What is the ratio of the Female Labor Force(as % of total labor force) in Virgin Islands in 1997 to that in 1998?
Your response must be concise. 1. What is the ratio of the Female Labor Force(as % of total labor force) of Bulgaria in 1997 to that in 1999?
Provide a short and direct response. 1.02. What is the ratio of the Female Labor Force(as % of total labor force) in Moldova in 1997 to that in 1999?
Make the answer very short. 0.99. What is the ratio of the Female Labor Force(as % of total labor force) of Bulgaria in 1998 to that in 1999?
Your answer should be very brief. 1.01. What is the ratio of the Female Labor Force(as % of total labor force) of Moldova in 1998 to that in 1999?
Your response must be concise. 1. What is the ratio of the Female Labor Force(as % of total labor force) in Virgin Islands in 1998 to that in 1999?
Make the answer very short. 0.99. What is the difference between the highest and the second highest Female Labor Force(as % of total labor force) in Bulgaria?
Keep it short and to the point. 0.26. What is the difference between the highest and the second highest Female Labor Force(as % of total labor force) of Moldova?
Your answer should be very brief. 0.24. What is the difference between the highest and the second highest Female Labor Force(as % of total labor force) in Virgin Islands?
Make the answer very short. 0.26. What is the difference between the highest and the lowest Female Labor Force(as % of total labor force) of Bulgaria?
Provide a succinct answer. 2.06. What is the difference between the highest and the lowest Female Labor Force(as % of total labor force) of Moldova?
Provide a short and direct response. 0.73. What is the difference between the highest and the lowest Female Labor Force(as % of total labor force) of Virgin Islands?
Offer a very short reply. 1.38. 